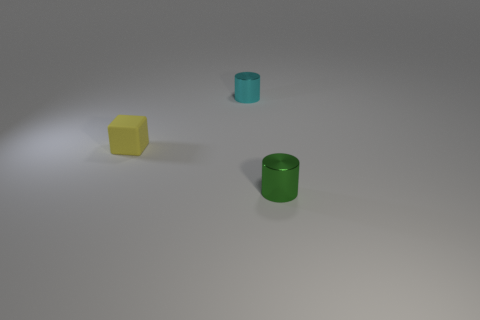Are there fewer tiny matte cubes than things?
Offer a terse response. Yes. What number of large things are either yellow shiny spheres or cyan metallic cylinders?
Give a very brief answer. 0. What number of metallic cylinders are behind the green cylinder and in front of the tiny yellow matte cube?
Your response must be concise. 0. Are there more shiny objects than green cylinders?
Offer a terse response. Yes. How many other objects are the same shape as the tiny rubber object?
Provide a succinct answer. 0. What material is the object that is both behind the green shiny cylinder and right of the matte cube?
Provide a succinct answer. Metal. How many things are in front of the small cylinder that is to the left of the tiny metallic thing that is on the right side of the cyan object?
Keep it short and to the point. 2. There is a yellow matte object that is behind the small metallic object on the right side of the tiny cyan thing; what shape is it?
Your response must be concise. Cube. What color is the small metallic cylinder behind the small yellow cube?
Provide a short and direct response. Cyan. The block behind the cylinder that is in front of the small cylinder that is on the left side of the green object is made of what material?
Make the answer very short. Rubber. 